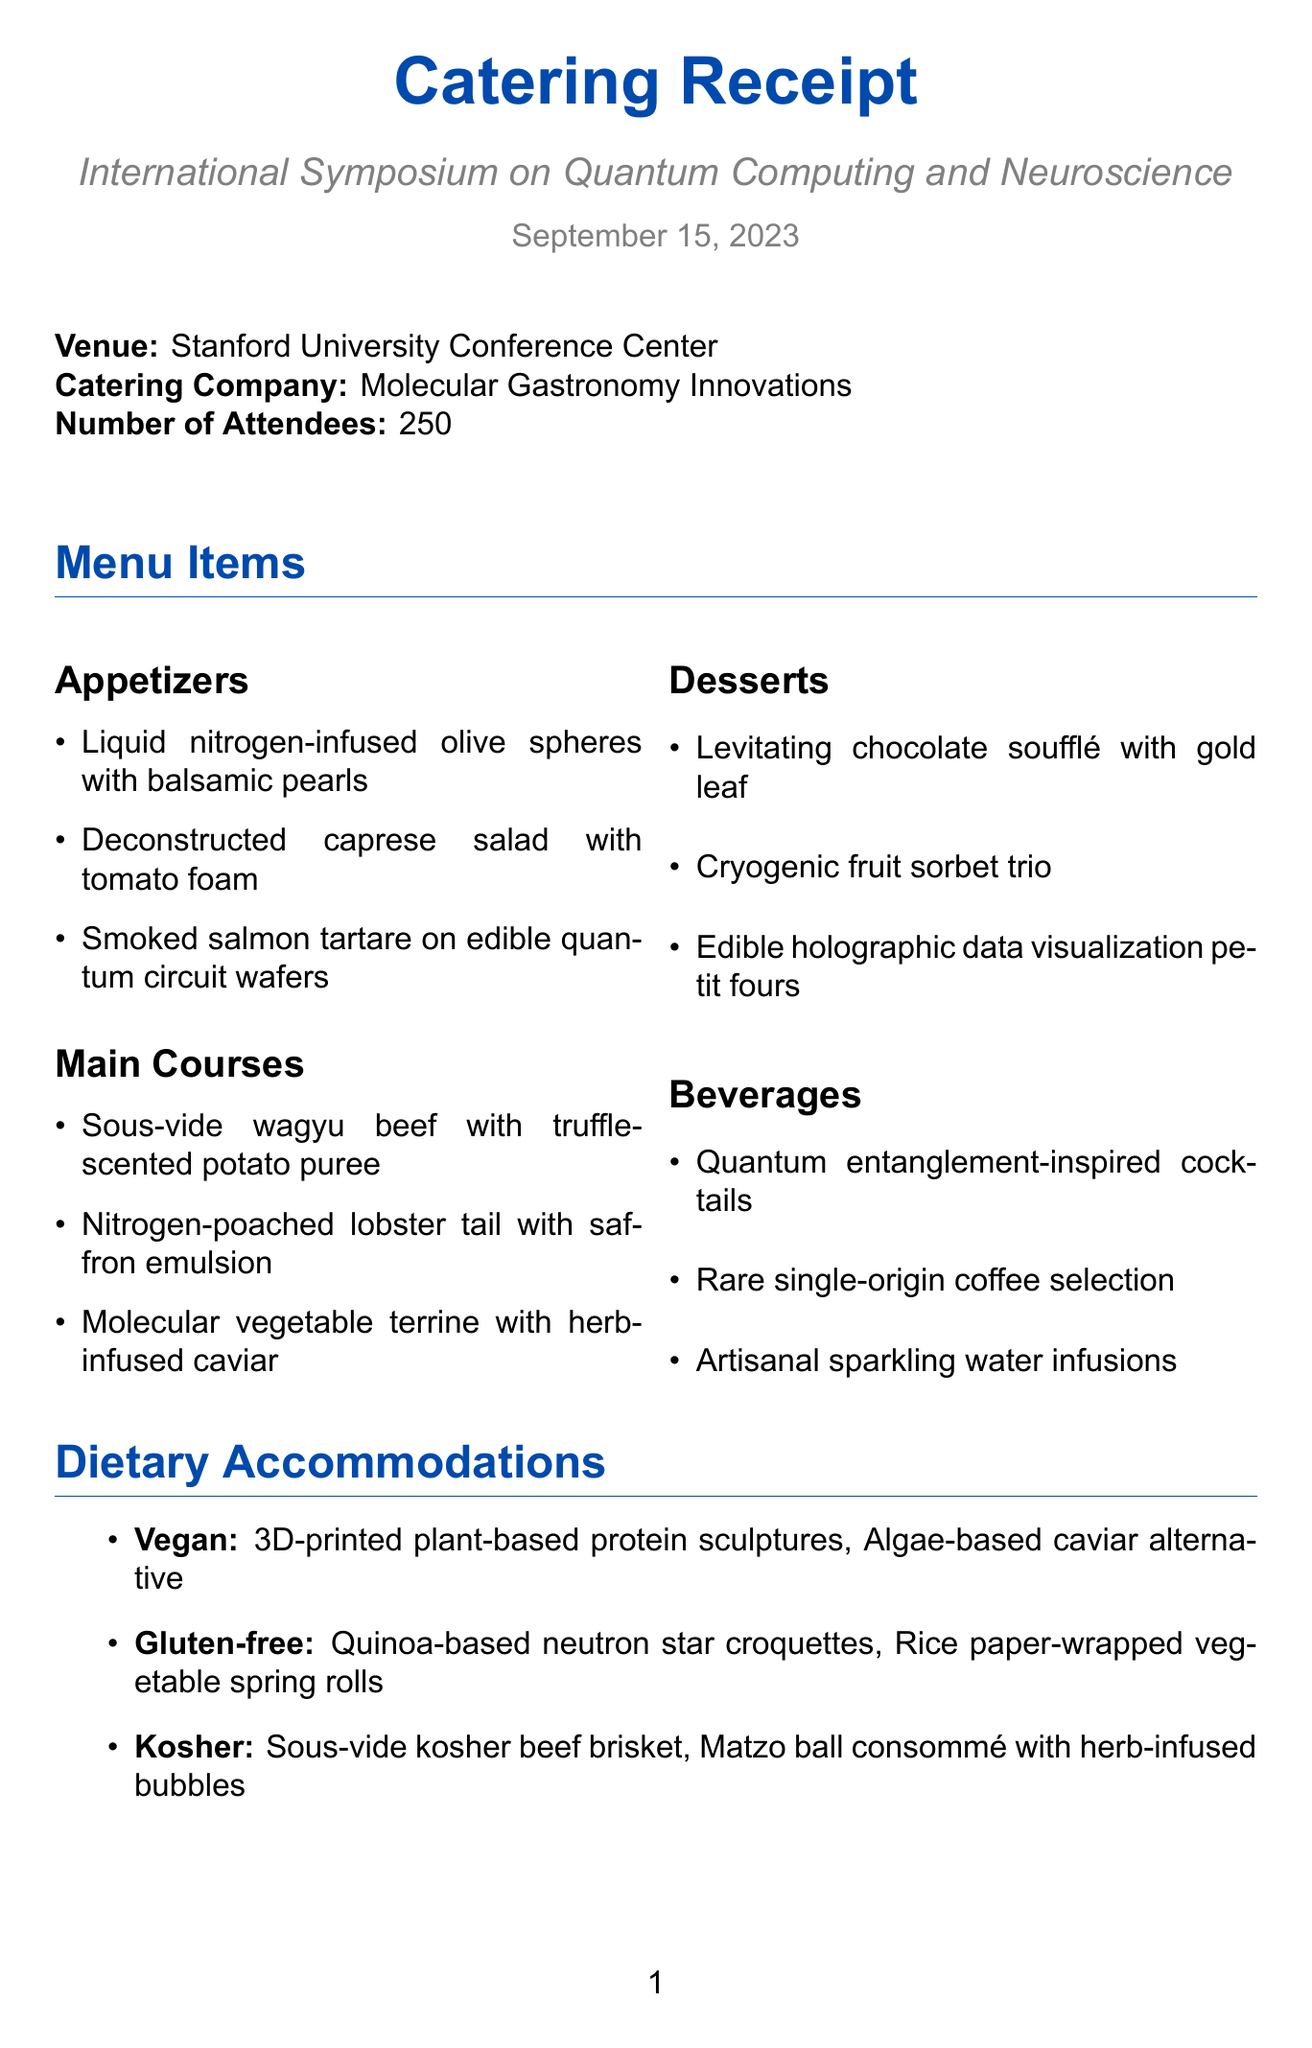What is the event name? The event name is explicitly stated at the beginning of the document.
Answer: International Symposium on Quantum Computing and Neuroscience What date is the event scheduled for? The date of the event is mentioned directly in the document.
Answer: September 15, 2023 How many attendees are expected? The number of attendees is provided in the document.
Answer: 250 What is the total cost for catering? The total cost for catering is stated clearly in the document.
Answer: $87,500 What dietary accommodation is available for vegans? The document lists specific dishes for vegan dietary accommodations.
Answer: 3D-printed plant-based protein sculptures What type of serving ware will be used? The document mentions sustainability measures that include the type of serving ware.
Answer: Compostable serving ware What feature allows for personalized meal recommendations? The document mentions a special feature that enables personalization.
Answer: Personalized meal recommendations based on attendee research interests What is the cost per person? The document states the cost per person clearly.
Answer: $350 What type of cuisine is the catering company known for? The name of the catering company suggests the type of cuisine they specialize in.
Answer: Molecular gastronomy 